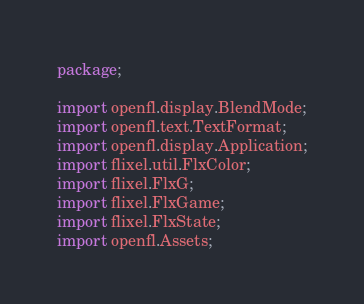<code> <loc_0><loc_0><loc_500><loc_500><_Haxe_>package;

import openfl.display.BlendMode;
import openfl.text.TextFormat;
import openfl.display.Application;
import flixel.util.FlxColor;
import flixel.FlxG;
import flixel.FlxGame;
import flixel.FlxState;
import openfl.Assets;</code> 